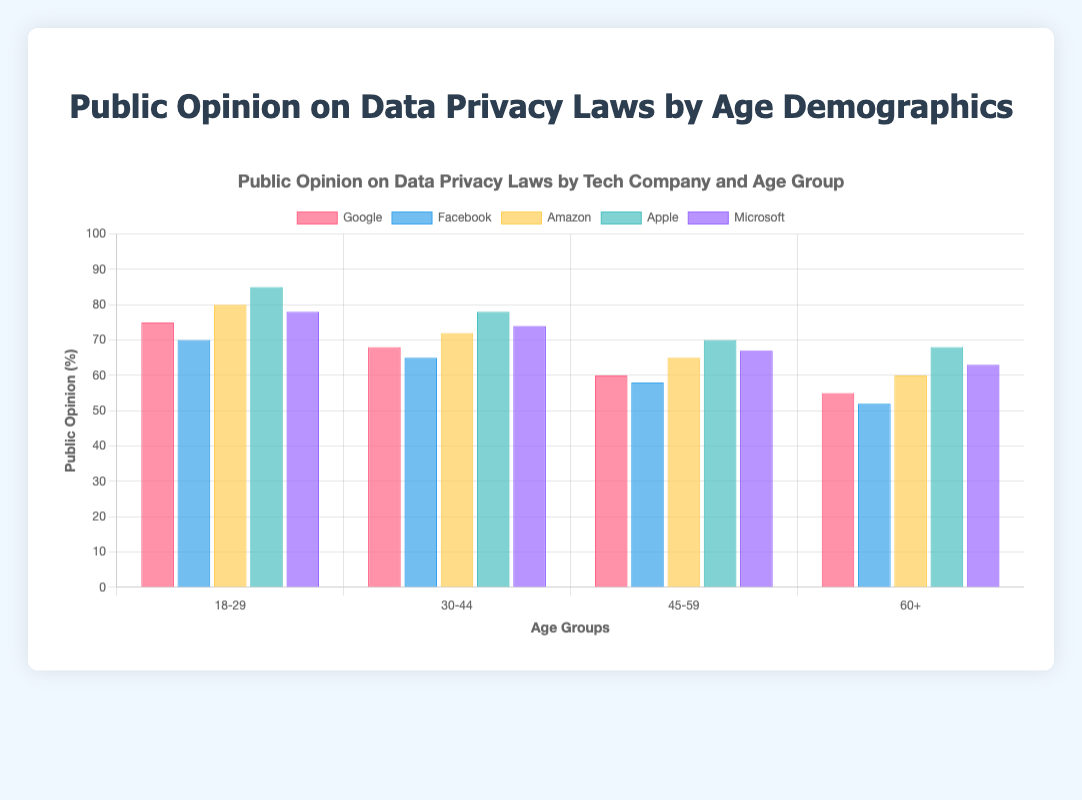Which age group shows the highest support for data privacy laws for Apple? By visually inspecting the height of the bars for Apple, the tallest bar corresponds to the 18-29 age group, indicating the highest support.
Answer: 18-29 What is the difference in support for data privacy laws between the 18-29 and 60+ age groups for Google? The support for Google in the 18-29 age group is 75%, and for the 60+ age group, it is 55%. The difference is 75% - 55% = 20%.
Answer: 20% Which company has the lowest support for data privacy laws among the 45-59 age group? By examining the bars for the 45-59 age group, the shortest bar is for Facebook, indicating the lowest support.
Answer: Facebook Among Microsoft and Amazon, which company shows higher support for data privacy laws in the 30-44 age group? By comparing the height of the bars for Microsoft and Amazon in the 30-44 age group, Amazon has a bar height of 72%, which is higher than Microsoft's 74%.
Answer: Microsoft What's the average support for data privacy laws across all age groups for Facebook? Add the percentage values for Facebook across all age groups (70 + 65 + 58 + 52) and divide by the number of groups (4). The average is (70 + 65 + 58 + 52) / 4 = 61.25%.
Answer: 61.25% Calculate the total support for data privacy laws across all age groups for Amazon and Apple combined. Sum the percentages for Amazon (80 + 72 + 65 + 60) and for Apple (85 + 78 + 70 + 68). The total support is (80 + 72 + 65 + 60) + (85 + 78 + 70 + 68) = 578%.
Answer: 578% Which company has the most consistent support across different age groups? By examining the bar heights and their variations, Microsoft appears to have the least variation among ages (78, 74, 67, 63), suggesting the most consistent support.
Answer: Microsoft For the 60+ age group, rank the companies from highest to lowest in terms of support for data privacy laws. By checking the bar heights for the 60+ age group, the order from highest to lowest support is Apple (68), Microsoft (63), Amazon (60), Google (55), and Facebook (52).
Answer: Apple, Microsoft, Amazon, Google, Facebook Compare the average support for data privacy laws between the 18-29 and 45-59 age groups across all companies. Calculate the average for the 18-29 group: (75 + 70 + 80 + 85 + 78) / 5 = 77.6%; and for the 45-59 group: (60 + 58 + 65 + 70 + 67) / 5 = 64%. The 18-29 group has a higher average support.
Answer: 77.6% vs. 64% Which age group has the largest variance in support for data privacy laws among the companies? By inspecting the range of bar heights for each age group, the 18-29 group shows the largest range (85 for Apple to 70 for Facebook), indicating the largest variance.
Answer: 18-29 